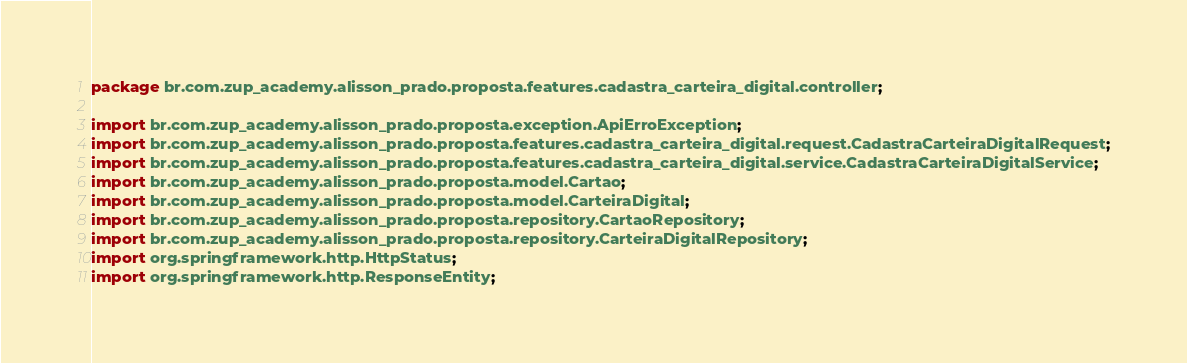Convert code to text. <code><loc_0><loc_0><loc_500><loc_500><_Java_>package br.com.zup_academy.alisson_prado.proposta.features.cadastra_carteira_digital.controller;

import br.com.zup_academy.alisson_prado.proposta.exception.ApiErroException;
import br.com.zup_academy.alisson_prado.proposta.features.cadastra_carteira_digital.request.CadastraCarteiraDigitalRequest;
import br.com.zup_academy.alisson_prado.proposta.features.cadastra_carteira_digital.service.CadastraCarteiraDigitalService;
import br.com.zup_academy.alisson_prado.proposta.model.Cartao;
import br.com.zup_academy.alisson_prado.proposta.model.CarteiraDigital;
import br.com.zup_academy.alisson_prado.proposta.repository.CartaoRepository;
import br.com.zup_academy.alisson_prado.proposta.repository.CarteiraDigitalRepository;
import org.springframework.http.HttpStatus;
import org.springframework.http.ResponseEntity;</code> 